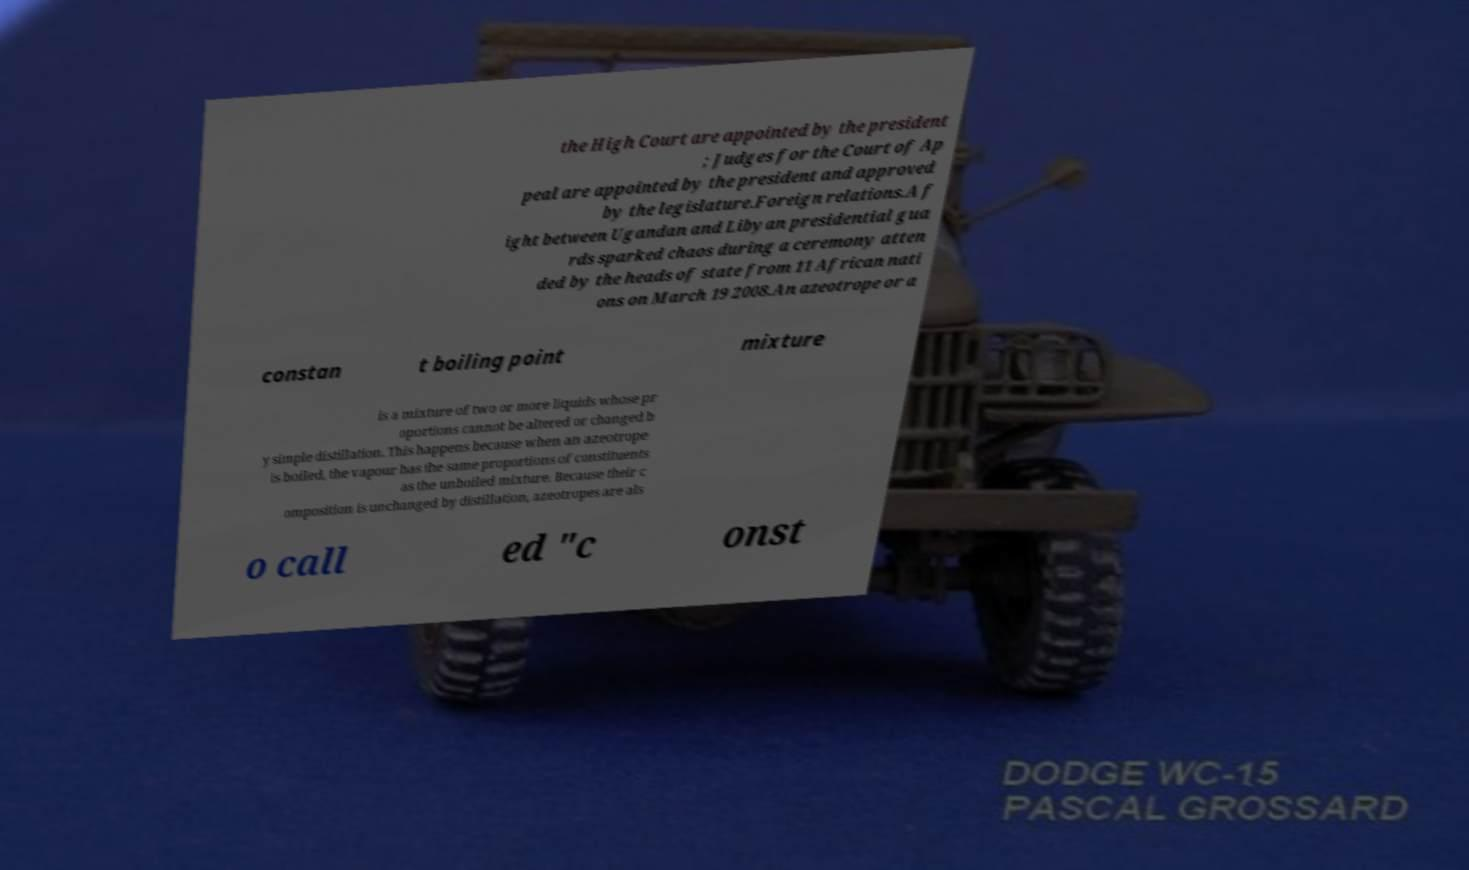I need the written content from this picture converted into text. Can you do that? the High Court are appointed by the president ; Judges for the Court of Ap peal are appointed by the president and approved by the legislature.Foreign relations.A f ight between Ugandan and Libyan presidential gua rds sparked chaos during a ceremony atten ded by the heads of state from 11 African nati ons on March 19 2008.An azeotrope or a constan t boiling point mixture is a mixture of two or more liquids whose pr oportions cannot be altered or changed b y simple distillation. This happens because when an azeotrope is boiled, the vapour has the same proportions of constituents as the unboiled mixture. Because their c omposition is unchanged by distillation, azeotropes are als o call ed "c onst 